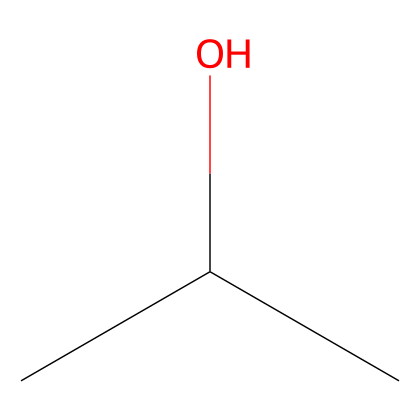How many carbon atoms are in this compound? The SMILES notation "CC(C)O" indicates there are three carbon atoms present (the two "C" at the beginning and one more "C" from the branching).
Answer: three What is the functional group present in this chemical? The "O" in the structure indicates the presence of a hydroxyl group (-OH), which is characteristic of alcohols.
Answer: hydroxyl What is the degree of branching in this structure? The structure has a branched configuration as indicated by the "C(C)" notation, showing that one carbon is attached to two other carbon chains (isobutanol), suggesting a single point of branching.
Answer: one What is the general class of this chemical? As identified by its functional group, which is an alcohol (due to the hydroxyl group), the general class of this compound is alcohol.
Answer: alcohol How many total hydrogen atoms are in this compound? The structure can be deduced as C3H8O. There are eight hydrogen atoms for this compound based on the tetravalency of carbon and the presence of the hydroxyl group.
Answer: eight Is this compound polar or non-polar? The presence of the hydroxyl group (-OH) contributes to polar characteristics due to the electronegative oxygen atom, making the compound polar.
Answer: polar 